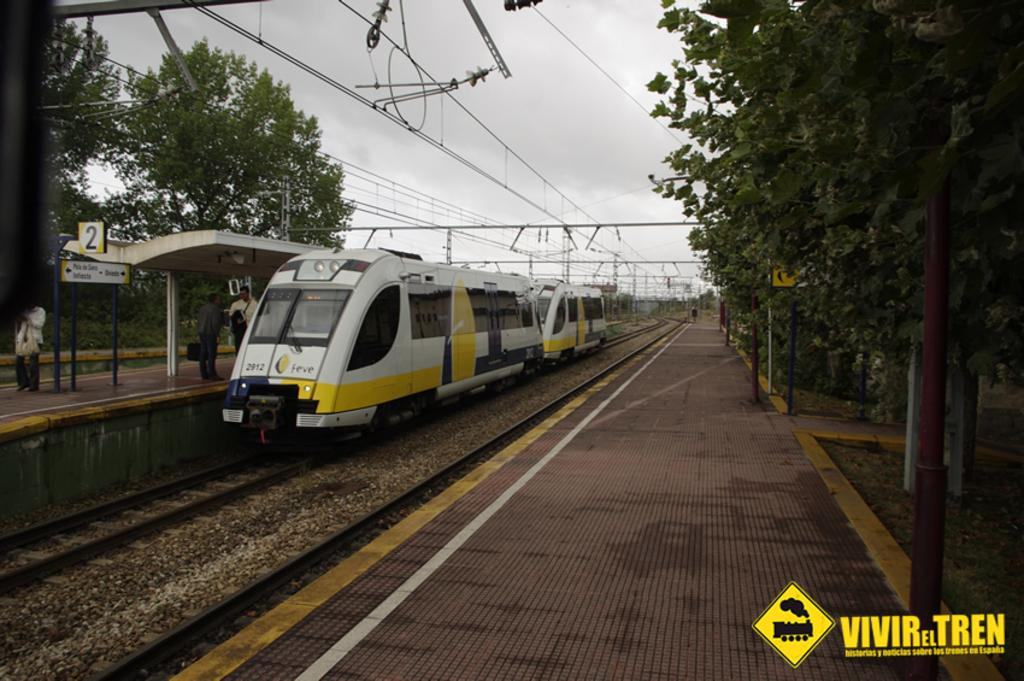<image>
Write a terse but informative summary of the picture. A train on the tracks has the number 2912 and the word feve on the front of it. 